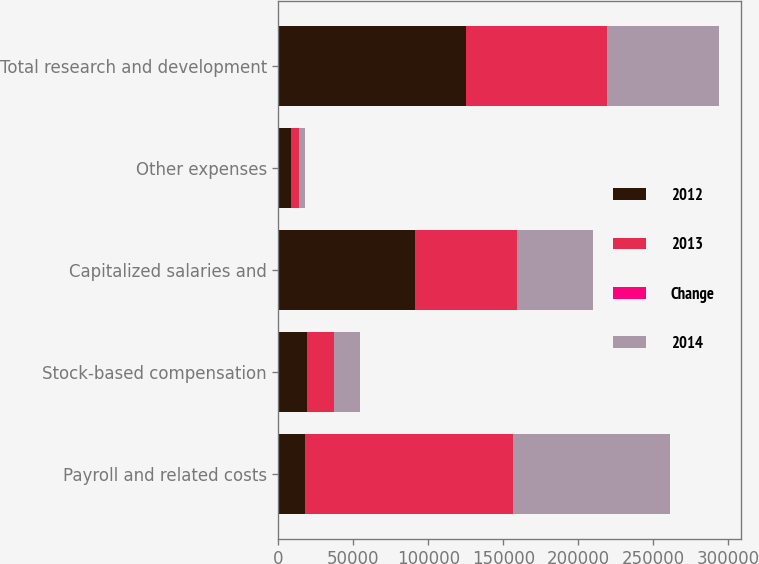Convert chart to OTSL. <chart><loc_0><loc_0><loc_500><loc_500><stacked_bar_chart><ecel><fcel>Payroll and related costs<fcel>Stock-based compensation<fcel>Capitalized salaries and<fcel>Other expenses<fcel>Total research and development<nl><fcel>2012<fcel>17472<fcel>19351<fcel>91106<fcel>8532<fcel>125286<nl><fcel>2013<fcel>139018<fcel>17472<fcel>67935<fcel>5324<fcel>93879<nl><fcel>Change<fcel>35.6<fcel>10.8<fcel>34.1<fcel>60.3<fcel>33.5<nl><fcel>2014<fcel>104244<fcel>17275<fcel>50648<fcel>3873<fcel>74744<nl></chart> 